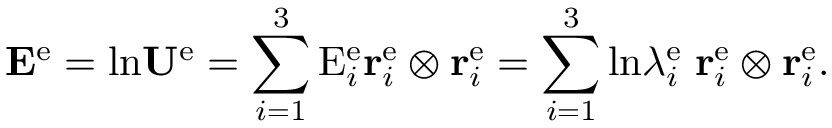Convert formula to latex. <formula><loc_0><loc_0><loc_500><loc_500>{ E } ^ { e } = \ln { U } ^ { e } = \sum _ { i = 1 } ^ { 3 } E _ { i } ^ { e } { r } _ { i } ^ { e } \otimes { r } _ { i } ^ { e } = \sum _ { i = 1 } ^ { 3 } \ln \lambda _ { i } ^ { e } \, { r } _ { i } ^ { e } \otimes { r } _ { i } ^ { e } .</formula> 